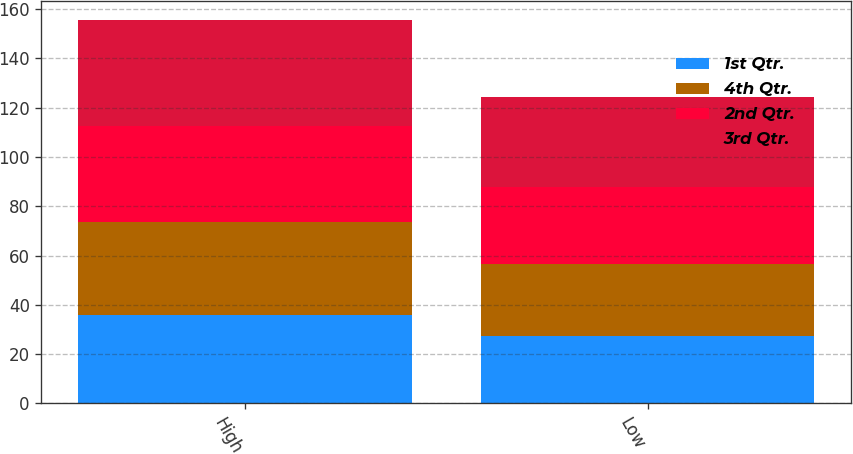<chart> <loc_0><loc_0><loc_500><loc_500><stacked_bar_chart><ecel><fcel>High<fcel>Low<nl><fcel>1st Qtr.<fcel>35.68<fcel>27.39<nl><fcel>4th Qtr.<fcel>37.76<fcel>29.24<nl><fcel>2nd Qtr.<fcel>39.28<fcel>31.15<nl><fcel>3rd Qtr.<fcel>42.89<fcel>36.39<nl></chart> 